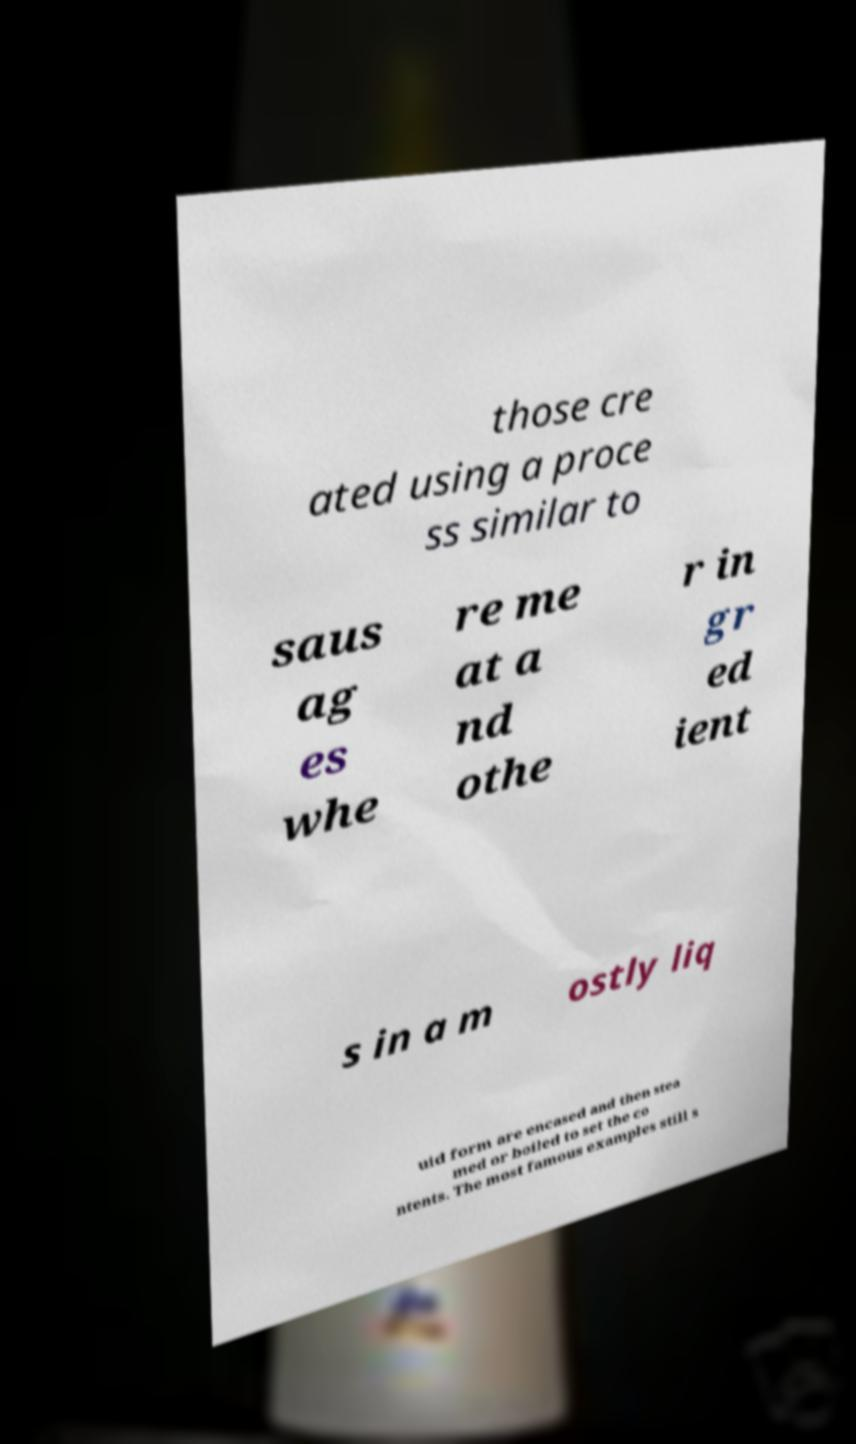Please read and relay the text visible in this image. What does it say? those cre ated using a proce ss similar to saus ag es whe re me at a nd othe r in gr ed ient s in a m ostly liq uid form are encased and then stea med or boiled to set the co ntents. The most famous examples still s 